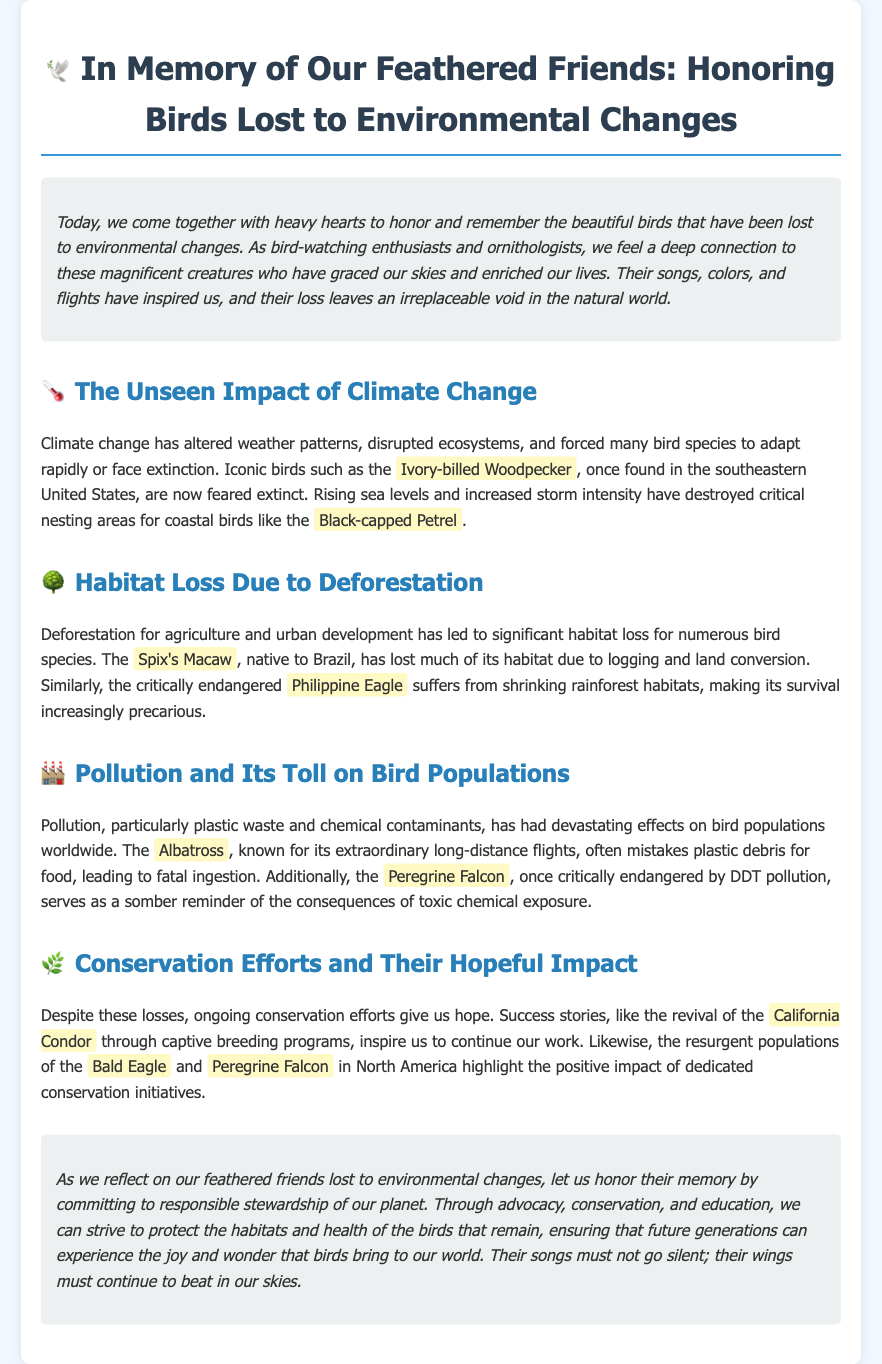what is the title of the document? The title is found at the beginning of the document as the main heading.
Answer: In Memory of Our Feathered Friends: Honoring Birds Lost to Environmental Changes what bird species is feared extinct? The document specifically mentions a bird species that is feared extinct due to environmental changes.
Answer: Ivory-billed Woodpecker which bird suffers from habitat loss due to logging and land conversion? The document cites a specific bird species affected by habitat loss as a result of human activities.
Answer: Spix's Macaw what is one of the consequences of pollution mentioned? The document discusses the impact of pollution on bird populations, specifically referencing a well-known bird.
Answer: Fatal ingestion what is one hopeful example of a conservation success? The document provides a specific success story in conservation that serves as inspiration.
Answer: California Condor how do conservation efforts impact populations of the Bald Eagle? The document explains the effect of conservation initiatives on a particular bird species.
Answer: Positive impact what does the document call for at the conclusion? The conclusion emphasizes a particular action that should be taken to honor lost birds.
Answer: Responsible stewardship which two birds are mentioned as resurgent in North America? The document lists two bird species that have experienced population recovery due to conservation efforts.
Answer: Bald Eagle and Peregrine Falcon 